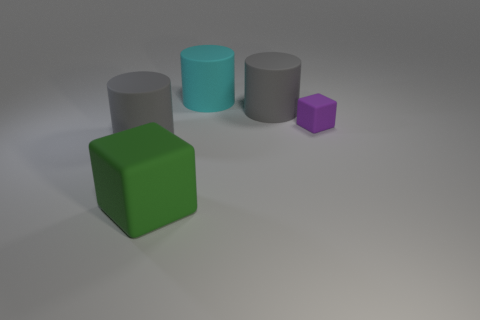Subtract all big gray cylinders. How many cylinders are left? 1 Subtract all cyan cylinders. How many cylinders are left? 2 Add 4 large blue matte cubes. How many objects exist? 9 Subtract all cylinders. How many objects are left? 2 Subtract 3 cylinders. How many cylinders are left? 0 Subtract all yellow blocks. Subtract all brown spheres. How many blocks are left? 2 Add 2 big cyan things. How many big cyan things are left? 3 Add 5 tiny blue blocks. How many tiny blue blocks exist? 5 Subtract 0 yellow balls. How many objects are left? 5 Subtract all red blocks. How many gray cylinders are left? 2 